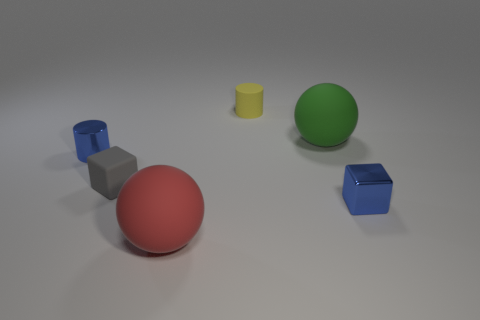Is the tiny rubber cylinder the same color as the small metallic cylinder?
Make the answer very short. No. There is a blue shiny object to the right of the rubber thing in front of the small gray matte block; how big is it?
Ensure brevity in your answer.  Small. Do the sphere that is behind the tiny gray object and the tiny blue thing that is on the left side of the large red object have the same material?
Provide a succinct answer. No. Does the ball left of the small yellow object have the same color as the shiny cylinder?
Offer a terse response. No. There is a large red ball; what number of matte cylinders are in front of it?
Your answer should be very brief. 0. Are the tiny blue block and the tiny cylinder on the left side of the yellow thing made of the same material?
Make the answer very short. Yes. There is a green ball that is made of the same material as the yellow cylinder; what size is it?
Make the answer very short. Large. Are there more tiny blocks behind the small yellow thing than green matte spheres behind the tiny gray rubber block?
Your response must be concise. No. Is there a big green object that has the same shape as the big red rubber object?
Give a very brief answer. Yes. Is the size of the red rubber sphere to the left of the yellow matte object the same as the green sphere?
Offer a very short reply. Yes. 